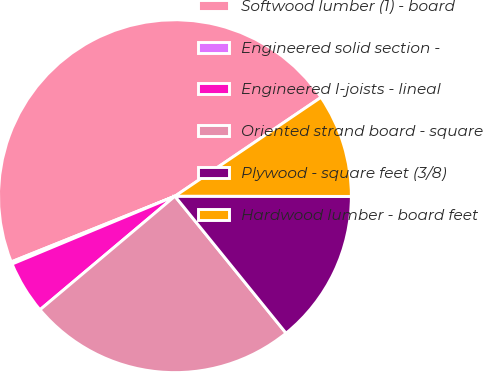<chart> <loc_0><loc_0><loc_500><loc_500><pie_chart><fcel>Softwood lumber (1) - board<fcel>Engineered solid section -<fcel>Engineered I-joists - lineal<fcel>Oriented strand board - square<fcel>Plywood - square feet (3/8)<fcel>Hardwood lumber - board feet<nl><fcel>46.6%<fcel>0.21%<fcel>4.85%<fcel>24.71%<fcel>14.13%<fcel>9.49%<nl></chart> 